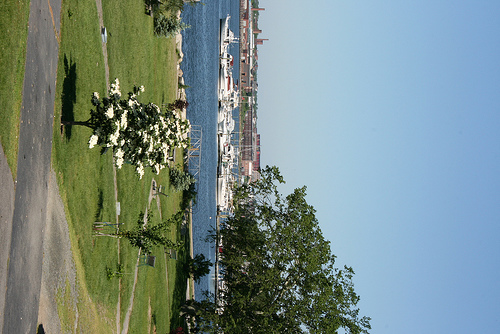<image>
Is there a flower on the grass? No. The flower is not positioned on the grass. They may be near each other, but the flower is not supported by or resting on top of the grass. 